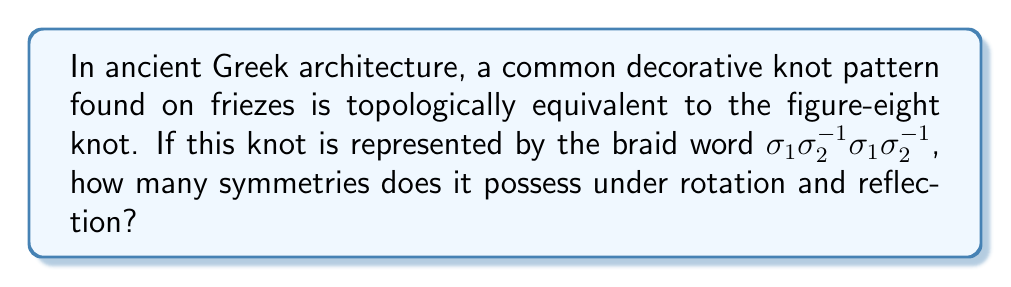Help me with this question. To determine the number of symmetries of the figure-eight knot as represented in ancient Greek architectural designs, we need to follow these steps:

1. Understand the braid representation:
   The braid word $\sigma_1\sigma_2^{-1}\sigma_1\sigma_2^{-1}$ represents the figure-eight knot.

2. Analyze the symmetries:
   a) Rotational symmetry:
      The figure-eight knot has a 2-fold rotational symmetry (180° rotation).
   
   b) Reflection symmetry:
      It has two planes of reflection symmetry.

3. Count the symmetries:
   - Identity (no change)
   - 180° rotation
   - Reflection across plane 1
   - Reflection across plane 2

4. Calculate total symmetries:
   Total symmetries = 4

This analysis reveals that the figure-eight knot, as commonly found in ancient Greek architectural designs, possesses 4 distinct symmetries under rotation and reflection.
Answer: 4 symmetries 